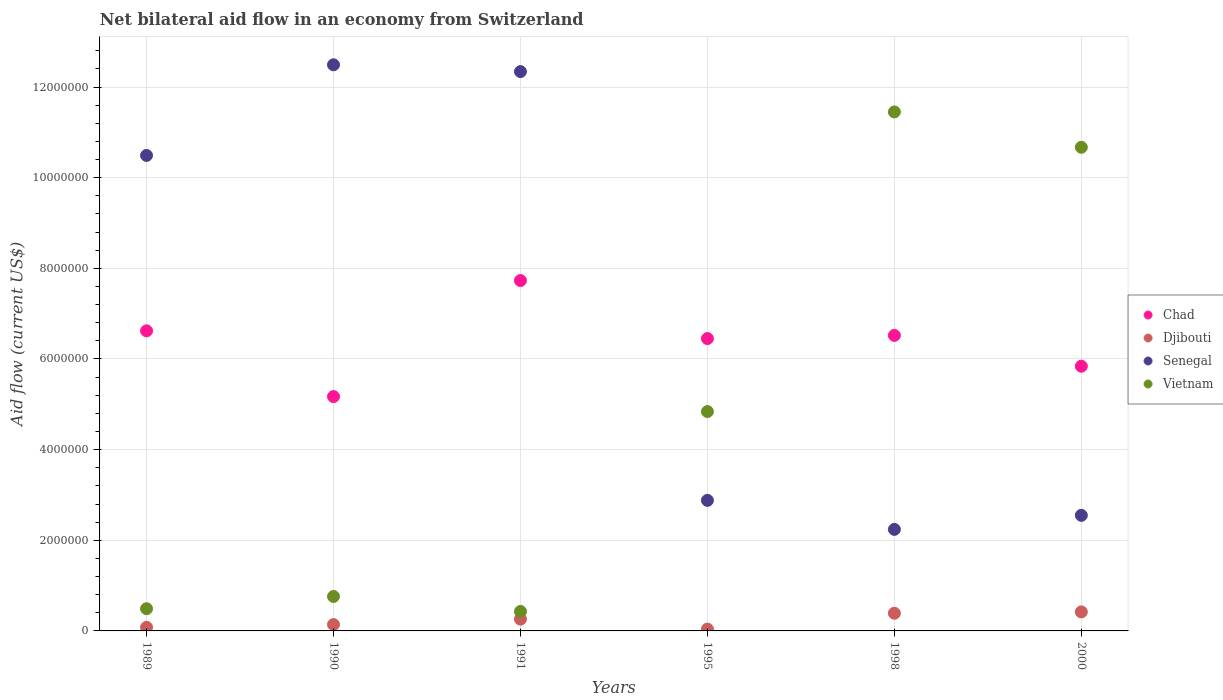How many different coloured dotlines are there?
Provide a short and direct response. 4. What is the net bilateral aid flow in Senegal in 1998?
Your answer should be compact. 2.24e+06. Across all years, what is the maximum net bilateral aid flow in Vietnam?
Your answer should be very brief. 1.14e+07. In which year was the net bilateral aid flow in Senegal minimum?
Make the answer very short. 1998. What is the total net bilateral aid flow in Chad in the graph?
Provide a succinct answer. 3.83e+07. What is the difference between the net bilateral aid flow in Vietnam in 1991 and that in 1995?
Your response must be concise. -4.41e+06. What is the difference between the net bilateral aid flow in Vietnam in 1995 and the net bilateral aid flow in Senegal in 2000?
Provide a short and direct response. 2.29e+06. What is the average net bilateral aid flow in Djibouti per year?
Make the answer very short. 2.22e+05. In the year 1989, what is the difference between the net bilateral aid flow in Djibouti and net bilateral aid flow in Chad?
Your answer should be very brief. -6.54e+06. What is the ratio of the net bilateral aid flow in Vietnam in 1995 to that in 2000?
Give a very brief answer. 0.45. Is the net bilateral aid flow in Chad in 1989 less than that in 1990?
Provide a succinct answer. No. Is the difference between the net bilateral aid flow in Djibouti in 1995 and 2000 greater than the difference between the net bilateral aid flow in Chad in 1995 and 2000?
Your answer should be compact. No. What is the difference between the highest and the second highest net bilateral aid flow in Djibouti?
Make the answer very short. 3.00e+04. Is the sum of the net bilateral aid flow in Vietnam in 1990 and 1991 greater than the maximum net bilateral aid flow in Chad across all years?
Give a very brief answer. No. Is it the case that in every year, the sum of the net bilateral aid flow in Vietnam and net bilateral aid flow in Chad  is greater than the sum of net bilateral aid flow in Senegal and net bilateral aid flow in Djibouti?
Keep it short and to the point. No. Is it the case that in every year, the sum of the net bilateral aid flow in Senegal and net bilateral aid flow in Djibouti  is greater than the net bilateral aid flow in Chad?
Ensure brevity in your answer.  No. Does the net bilateral aid flow in Vietnam monotonically increase over the years?
Offer a very short reply. No. Is the net bilateral aid flow in Djibouti strictly greater than the net bilateral aid flow in Vietnam over the years?
Make the answer very short. No. How many dotlines are there?
Keep it short and to the point. 4. How many years are there in the graph?
Your answer should be very brief. 6. Are the values on the major ticks of Y-axis written in scientific E-notation?
Give a very brief answer. No. How many legend labels are there?
Your response must be concise. 4. What is the title of the graph?
Offer a very short reply. Net bilateral aid flow in an economy from Switzerland. Does "Myanmar" appear as one of the legend labels in the graph?
Provide a succinct answer. No. What is the Aid flow (current US$) of Chad in 1989?
Your response must be concise. 6.62e+06. What is the Aid flow (current US$) of Senegal in 1989?
Make the answer very short. 1.05e+07. What is the Aid flow (current US$) in Chad in 1990?
Keep it short and to the point. 5.17e+06. What is the Aid flow (current US$) in Djibouti in 1990?
Your answer should be compact. 1.40e+05. What is the Aid flow (current US$) in Senegal in 1990?
Give a very brief answer. 1.25e+07. What is the Aid flow (current US$) in Vietnam in 1990?
Your answer should be very brief. 7.60e+05. What is the Aid flow (current US$) in Chad in 1991?
Keep it short and to the point. 7.73e+06. What is the Aid flow (current US$) in Senegal in 1991?
Make the answer very short. 1.23e+07. What is the Aid flow (current US$) of Vietnam in 1991?
Ensure brevity in your answer.  4.30e+05. What is the Aid flow (current US$) in Chad in 1995?
Make the answer very short. 6.45e+06. What is the Aid flow (current US$) of Djibouti in 1995?
Give a very brief answer. 4.00e+04. What is the Aid flow (current US$) in Senegal in 1995?
Offer a terse response. 2.88e+06. What is the Aid flow (current US$) in Vietnam in 1995?
Give a very brief answer. 4.84e+06. What is the Aid flow (current US$) of Chad in 1998?
Your response must be concise. 6.52e+06. What is the Aid flow (current US$) of Senegal in 1998?
Offer a very short reply. 2.24e+06. What is the Aid flow (current US$) in Vietnam in 1998?
Your answer should be compact. 1.14e+07. What is the Aid flow (current US$) of Chad in 2000?
Offer a very short reply. 5.84e+06. What is the Aid flow (current US$) of Djibouti in 2000?
Offer a terse response. 4.20e+05. What is the Aid flow (current US$) of Senegal in 2000?
Your answer should be very brief. 2.55e+06. What is the Aid flow (current US$) of Vietnam in 2000?
Your response must be concise. 1.07e+07. Across all years, what is the maximum Aid flow (current US$) of Chad?
Provide a short and direct response. 7.73e+06. Across all years, what is the maximum Aid flow (current US$) in Senegal?
Offer a very short reply. 1.25e+07. Across all years, what is the maximum Aid flow (current US$) of Vietnam?
Make the answer very short. 1.14e+07. Across all years, what is the minimum Aid flow (current US$) of Chad?
Make the answer very short. 5.17e+06. Across all years, what is the minimum Aid flow (current US$) in Djibouti?
Your answer should be compact. 4.00e+04. Across all years, what is the minimum Aid flow (current US$) of Senegal?
Keep it short and to the point. 2.24e+06. Across all years, what is the minimum Aid flow (current US$) of Vietnam?
Ensure brevity in your answer.  4.30e+05. What is the total Aid flow (current US$) in Chad in the graph?
Make the answer very short. 3.83e+07. What is the total Aid flow (current US$) of Djibouti in the graph?
Your answer should be very brief. 1.33e+06. What is the total Aid flow (current US$) of Senegal in the graph?
Ensure brevity in your answer.  4.30e+07. What is the total Aid flow (current US$) in Vietnam in the graph?
Make the answer very short. 2.86e+07. What is the difference between the Aid flow (current US$) in Chad in 1989 and that in 1990?
Ensure brevity in your answer.  1.45e+06. What is the difference between the Aid flow (current US$) in Djibouti in 1989 and that in 1990?
Keep it short and to the point. -6.00e+04. What is the difference between the Aid flow (current US$) in Vietnam in 1989 and that in 1990?
Make the answer very short. -2.70e+05. What is the difference between the Aid flow (current US$) of Chad in 1989 and that in 1991?
Offer a very short reply. -1.11e+06. What is the difference between the Aid flow (current US$) of Senegal in 1989 and that in 1991?
Offer a terse response. -1.85e+06. What is the difference between the Aid flow (current US$) of Djibouti in 1989 and that in 1995?
Offer a very short reply. 4.00e+04. What is the difference between the Aid flow (current US$) in Senegal in 1989 and that in 1995?
Keep it short and to the point. 7.61e+06. What is the difference between the Aid flow (current US$) in Vietnam in 1989 and that in 1995?
Your answer should be compact. -4.35e+06. What is the difference between the Aid flow (current US$) in Djibouti in 1989 and that in 1998?
Keep it short and to the point. -3.10e+05. What is the difference between the Aid flow (current US$) in Senegal in 1989 and that in 1998?
Ensure brevity in your answer.  8.25e+06. What is the difference between the Aid flow (current US$) of Vietnam in 1989 and that in 1998?
Make the answer very short. -1.10e+07. What is the difference between the Aid flow (current US$) of Chad in 1989 and that in 2000?
Keep it short and to the point. 7.80e+05. What is the difference between the Aid flow (current US$) of Djibouti in 1989 and that in 2000?
Your answer should be compact. -3.40e+05. What is the difference between the Aid flow (current US$) of Senegal in 1989 and that in 2000?
Ensure brevity in your answer.  7.94e+06. What is the difference between the Aid flow (current US$) of Vietnam in 1989 and that in 2000?
Your answer should be compact. -1.02e+07. What is the difference between the Aid flow (current US$) in Chad in 1990 and that in 1991?
Offer a terse response. -2.56e+06. What is the difference between the Aid flow (current US$) of Chad in 1990 and that in 1995?
Make the answer very short. -1.28e+06. What is the difference between the Aid flow (current US$) of Djibouti in 1990 and that in 1995?
Provide a succinct answer. 1.00e+05. What is the difference between the Aid flow (current US$) in Senegal in 1990 and that in 1995?
Your answer should be compact. 9.61e+06. What is the difference between the Aid flow (current US$) of Vietnam in 1990 and that in 1995?
Offer a very short reply. -4.08e+06. What is the difference between the Aid flow (current US$) of Chad in 1990 and that in 1998?
Your answer should be compact. -1.35e+06. What is the difference between the Aid flow (current US$) of Djibouti in 1990 and that in 1998?
Make the answer very short. -2.50e+05. What is the difference between the Aid flow (current US$) of Senegal in 1990 and that in 1998?
Offer a terse response. 1.02e+07. What is the difference between the Aid flow (current US$) of Vietnam in 1990 and that in 1998?
Your answer should be very brief. -1.07e+07. What is the difference between the Aid flow (current US$) of Chad in 1990 and that in 2000?
Give a very brief answer. -6.70e+05. What is the difference between the Aid flow (current US$) of Djibouti in 1990 and that in 2000?
Offer a terse response. -2.80e+05. What is the difference between the Aid flow (current US$) of Senegal in 1990 and that in 2000?
Offer a terse response. 9.94e+06. What is the difference between the Aid flow (current US$) in Vietnam in 1990 and that in 2000?
Ensure brevity in your answer.  -9.91e+06. What is the difference between the Aid flow (current US$) of Chad in 1991 and that in 1995?
Offer a terse response. 1.28e+06. What is the difference between the Aid flow (current US$) of Djibouti in 1991 and that in 1995?
Offer a very short reply. 2.20e+05. What is the difference between the Aid flow (current US$) of Senegal in 1991 and that in 1995?
Offer a terse response. 9.46e+06. What is the difference between the Aid flow (current US$) of Vietnam in 1991 and that in 1995?
Keep it short and to the point. -4.41e+06. What is the difference between the Aid flow (current US$) in Chad in 1991 and that in 1998?
Your response must be concise. 1.21e+06. What is the difference between the Aid flow (current US$) of Djibouti in 1991 and that in 1998?
Give a very brief answer. -1.30e+05. What is the difference between the Aid flow (current US$) in Senegal in 1991 and that in 1998?
Offer a terse response. 1.01e+07. What is the difference between the Aid flow (current US$) in Vietnam in 1991 and that in 1998?
Provide a succinct answer. -1.10e+07. What is the difference between the Aid flow (current US$) of Chad in 1991 and that in 2000?
Make the answer very short. 1.89e+06. What is the difference between the Aid flow (current US$) in Senegal in 1991 and that in 2000?
Ensure brevity in your answer.  9.79e+06. What is the difference between the Aid flow (current US$) in Vietnam in 1991 and that in 2000?
Keep it short and to the point. -1.02e+07. What is the difference between the Aid flow (current US$) of Djibouti in 1995 and that in 1998?
Offer a very short reply. -3.50e+05. What is the difference between the Aid flow (current US$) in Senegal in 1995 and that in 1998?
Your answer should be compact. 6.40e+05. What is the difference between the Aid flow (current US$) in Vietnam in 1995 and that in 1998?
Ensure brevity in your answer.  -6.61e+06. What is the difference between the Aid flow (current US$) of Chad in 1995 and that in 2000?
Your answer should be very brief. 6.10e+05. What is the difference between the Aid flow (current US$) of Djibouti in 1995 and that in 2000?
Offer a very short reply. -3.80e+05. What is the difference between the Aid flow (current US$) of Vietnam in 1995 and that in 2000?
Provide a short and direct response. -5.83e+06. What is the difference between the Aid flow (current US$) of Chad in 1998 and that in 2000?
Offer a very short reply. 6.80e+05. What is the difference between the Aid flow (current US$) in Djibouti in 1998 and that in 2000?
Make the answer very short. -3.00e+04. What is the difference between the Aid flow (current US$) in Senegal in 1998 and that in 2000?
Ensure brevity in your answer.  -3.10e+05. What is the difference between the Aid flow (current US$) of Vietnam in 1998 and that in 2000?
Your answer should be very brief. 7.80e+05. What is the difference between the Aid flow (current US$) of Chad in 1989 and the Aid flow (current US$) of Djibouti in 1990?
Give a very brief answer. 6.48e+06. What is the difference between the Aid flow (current US$) in Chad in 1989 and the Aid flow (current US$) in Senegal in 1990?
Provide a short and direct response. -5.87e+06. What is the difference between the Aid flow (current US$) in Chad in 1989 and the Aid flow (current US$) in Vietnam in 1990?
Ensure brevity in your answer.  5.86e+06. What is the difference between the Aid flow (current US$) of Djibouti in 1989 and the Aid flow (current US$) of Senegal in 1990?
Provide a short and direct response. -1.24e+07. What is the difference between the Aid flow (current US$) of Djibouti in 1989 and the Aid flow (current US$) of Vietnam in 1990?
Your response must be concise. -6.80e+05. What is the difference between the Aid flow (current US$) of Senegal in 1989 and the Aid flow (current US$) of Vietnam in 1990?
Offer a very short reply. 9.73e+06. What is the difference between the Aid flow (current US$) of Chad in 1989 and the Aid flow (current US$) of Djibouti in 1991?
Offer a very short reply. 6.36e+06. What is the difference between the Aid flow (current US$) in Chad in 1989 and the Aid flow (current US$) in Senegal in 1991?
Your answer should be very brief. -5.72e+06. What is the difference between the Aid flow (current US$) in Chad in 1989 and the Aid flow (current US$) in Vietnam in 1991?
Keep it short and to the point. 6.19e+06. What is the difference between the Aid flow (current US$) in Djibouti in 1989 and the Aid flow (current US$) in Senegal in 1991?
Give a very brief answer. -1.23e+07. What is the difference between the Aid flow (current US$) of Djibouti in 1989 and the Aid flow (current US$) of Vietnam in 1991?
Keep it short and to the point. -3.50e+05. What is the difference between the Aid flow (current US$) of Senegal in 1989 and the Aid flow (current US$) of Vietnam in 1991?
Make the answer very short. 1.01e+07. What is the difference between the Aid flow (current US$) in Chad in 1989 and the Aid flow (current US$) in Djibouti in 1995?
Your answer should be very brief. 6.58e+06. What is the difference between the Aid flow (current US$) of Chad in 1989 and the Aid flow (current US$) of Senegal in 1995?
Your answer should be compact. 3.74e+06. What is the difference between the Aid flow (current US$) in Chad in 1989 and the Aid flow (current US$) in Vietnam in 1995?
Provide a short and direct response. 1.78e+06. What is the difference between the Aid flow (current US$) of Djibouti in 1989 and the Aid flow (current US$) of Senegal in 1995?
Your answer should be compact. -2.80e+06. What is the difference between the Aid flow (current US$) of Djibouti in 1989 and the Aid flow (current US$) of Vietnam in 1995?
Make the answer very short. -4.76e+06. What is the difference between the Aid flow (current US$) in Senegal in 1989 and the Aid flow (current US$) in Vietnam in 1995?
Your answer should be compact. 5.65e+06. What is the difference between the Aid flow (current US$) in Chad in 1989 and the Aid flow (current US$) in Djibouti in 1998?
Keep it short and to the point. 6.23e+06. What is the difference between the Aid flow (current US$) of Chad in 1989 and the Aid flow (current US$) of Senegal in 1998?
Give a very brief answer. 4.38e+06. What is the difference between the Aid flow (current US$) in Chad in 1989 and the Aid flow (current US$) in Vietnam in 1998?
Give a very brief answer. -4.83e+06. What is the difference between the Aid flow (current US$) in Djibouti in 1989 and the Aid flow (current US$) in Senegal in 1998?
Make the answer very short. -2.16e+06. What is the difference between the Aid flow (current US$) of Djibouti in 1989 and the Aid flow (current US$) of Vietnam in 1998?
Offer a very short reply. -1.14e+07. What is the difference between the Aid flow (current US$) of Senegal in 1989 and the Aid flow (current US$) of Vietnam in 1998?
Your response must be concise. -9.60e+05. What is the difference between the Aid flow (current US$) in Chad in 1989 and the Aid flow (current US$) in Djibouti in 2000?
Provide a succinct answer. 6.20e+06. What is the difference between the Aid flow (current US$) in Chad in 1989 and the Aid flow (current US$) in Senegal in 2000?
Provide a short and direct response. 4.07e+06. What is the difference between the Aid flow (current US$) of Chad in 1989 and the Aid flow (current US$) of Vietnam in 2000?
Give a very brief answer. -4.05e+06. What is the difference between the Aid flow (current US$) in Djibouti in 1989 and the Aid flow (current US$) in Senegal in 2000?
Provide a succinct answer. -2.47e+06. What is the difference between the Aid flow (current US$) of Djibouti in 1989 and the Aid flow (current US$) of Vietnam in 2000?
Offer a very short reply. -1.06e+07. What is the difference between the Aid flow (current US$) of Chad in 1990 and the Aid flow (current US$) of Djibouti in 1991?
Your answer should be very brief. 4.91e+06. What is the difference between the Aid flow (current US$) of Chad in 1990 and the Aid flow (current US$) of Senegal in 1991?
Your response must be concise. -7.17e+06. What is the difference between the Aid flow (current US$) of Chad in 1990 and the Aid flow (current US$) of Vietnam in 1991?
Ensure brevity in your answer.  4.74e+06. What is the difference between the Aid flow (current US$) of Djibouti in 1990 and the Aid flow (current US$) of Senegal in 1991?
Offer a very short reply. -1.22e+07. What is the difference between the Aid flow (current US$) in Djibouti in 1990 and the Aid flow (current US$) in Vietnam in 1991?
Offer a very short reply. -2.90e+05. What is the difference between the Aid flow (current US$) in Senegal in 1990 and the Aid flow (current US$) in Vietnam in 1991?
Ensure brevity in your answer.  1.21e+07. What is the difference between the Aid flow (current US$) of Chad in 1990 and the Aid flow (current US$) of Djibouti in 1995?
Your answer should be very brief. 5.13e+06. What is the difference between the Aid flow (current US$) in Chad in 1990 and the Aid flow (current US$) in Senegal in 1995?
Provide a short and direct response. 2.29e+06. What is the difference between the Aid flow (current US$) of Djibouti in 1990 and the Aid flow (current US$) of Senegal in 1995?
Provide a short and direct response. -2.74e+06. What is the difference between the Aid flow (current US$) in Djibouti in 1990 and the Aid flow (current US$) in Vietnam in 1995?
Keep it short and to the point. -4.70e+06. What is the difference between the Aid flow (current US$) in Senegal in 1990 and the Aid flow (current US$) in Vietnam in 1995?
Make the answer very short. 7.65e+06. What is the difference between the Aid flow (current US$) of Chad in 1990 and the Aid flow (current US$) of Djibouti in 1998?
Keep it short and to the point. 4.78e+06. What is the difference between the Aid flow (current US$) in Chad in 1990 and the Aid flow (current US$) in Senegal in 1998?
Give a very brief answer. 2.93e+06. What is the difference between the Aid flow (current US$) in Chad in 1990 and the Aid flow (current US$) in Vietnam in 1998?
Your response must be concise. -6.28e+06. What is the difference between the Aid flow (current US$) in Djibouti in 1990 and the Aid flow (current US$) in Senegal in 1998?
Offer a terse response. -2.10e+06. What is the difference between the Aid flow (current US$) of Djibouti in 1990 and the Aid flow (current US$) of Vietnam in 1998?
Keep it short and to the point. -1.13e+07. What is the difference between the Aid flow (current US$) in Senegal in 1990 and the Aid flow (current US$) in Vietnam in 1998?
Provide a short and direct response. 1.04e+06. What is the difference between the Aid flow (current US$) in Chad in 1990 and the Aid flow (current US$) in Djibouti in 2000?
Provide a succinct answer. 4.75e+06. What is the difference between the Aid flow (current US$) of Chad in 1990 and the Aid flow (current US$) of Senegal in 2000?
Your answer should be compact. 2.62e+06. What is the difference between the Aid flow (current US$) of Chad in 1990 and the Aid flow (current US$) of Vietnam in 2000?
Your response must be concise. -5.50e+06. What is the difference between the Aid flow (current US$) in Djibouti in 1990 and the Aid flow (current US$) in Senegal in 2000?
Offer a very short reply. -2.41e+06. What is the difference between the Aid flow (current US$) of Djibouti in 1990 and the Aid flow (current US$) of Vietnam in 2000?
Keep it short and to the point. -1.05e+07. What is the difference between the Aid flow (current US$) in Senegal in 1990 and the Aid flow (current US$) in Vietnam in 2000?
Ensure brevity in your answer.  1.82e+06. What is the difference between the Aid flow (current US$) in Chad in 1991 and the Aid flow (current US$) in Djibouti in 1995?
Your answer should be compact. 7.69e+06. What is the difference between the Aid flow (current US$) of Chad in 1991 and the Aid flow (current US$) of Senegal in 1995?
Keep it short and to the point. 4.85e+06. What is the difference between the Aid flow (current US$) in Chad in 1991 and the Aid flow (current US$) in Vietnam in 1995?
Your answer should be compact. 2.89e+06. What is the difference between the Aid flow (current US$) of Djibouti in 1991 and the Aid flow (current US$) of Senegal in 1995?
Provide a succinct answer. -2.62e+06. What is the difference between the Aid flow (current US$) in Djibouti in 1991 and the Aid flow (current US$) in Vietnam in 1995?
Your answer should be compact. -4.58e+06. What is the difference between the Aid flow (current US$) of Senegal in 1991 and the Aid flow (current US$) of Vietnam in 1995?
Provide a succinct answer. 7.50e+06. What is the difference between the Aid flow (current US$) in Chad in 1991 and the Aid flow (current US$) in Djibouti in 1998?
Offer a terse response. 7.34e+06. What is the difference between the Aid flow (current US$) of Chad in 1991 and the Aid flow (current US$) of Senegal in 1998?
Keep it short and to the point. 5.49e+06. What is the difference between the Aid flow (current US$) of Chad in 1991 and the Aid flow (current US$) of Vietnam in 1998?
Make the answer very short. -3.72e+06. What is the difference between the Aid flow (current US$) in Djibouti in 1991 and the Aid flow (current US$) in Senegal in 1998?
Make the answer very short. -1.98e+06. What is the difference between the Aid flow (current US$) in Djibouti in 1991 and the Aid flow (current US$) in Vietnam in 1998?
Provide a succinct answer. -1.12e+07. What is the difference between the Aid flow (current US$) of Senegal in 1991 and the Aid flow (current US$) of Vietnam in 1998?
Your answer should be very brief. 8.90e+05. What is the difference between the Aid flow (current US$) of Chad in 1991 and the Aid flow (current US$) of Djibouti in 2000?
Offer a very short reply. 7.31e+06. What is the difference between the Aid flow (current US$) of Chad in 1991 and the Aid flow (current US$) of Senegal in 2000?
Make the answer very short. 5.18e+06. What is the difference between the Aid flow (current US$) in Chad in 1991 and the Aid flow (current US$) in Vietnam in 2000?
Ensure brevity in your answer.  -2.94e+06. What is the difference between the Aid flow (current US$) in Djibouti in 1991 and the Aid flow (current US$) in Senegal in 2000?
Offer a very short reply. -2.29e+06. What is the difference between the Aid flow (current US$) of Djibouti in 1991 and the Aid flow (current US$) of Vietnam in 2000?
Ensure brevity in your answer.  -1.04e+07. What is the difference between the Aid flow (current US$) of Senegal in 1991 and the Aid flow (current US$) of Vietnam in 2000?
Provide a short and direct response. 1.67e+06. What is the difference between the Aid flow (current US$) of Chad in 1995 and the Aid flow (current US$) of Djibouti in 1998?
Ensure brevity in your answer.  6.06e+06. What is the difference between the Aid flow (current US$) in Chad in 1995 and the Aid flow (current US$) in Senegal in 1998?
Give a very brief answer. 4.21e+06. What is the difference between the Aid flow (current US$) of Chad in 1995 and the Aid flow (current US$) of Vietnam in 1998?
Make the answer very short. -5.00e+06. What is the difference between the Aid flow (current US$) of Djibouti in 1995 and the Aid flow (current US$) of Senegal in 1998?
Make the answer very short. -2.20e+06. What is the difference between the Aid flow (current US$) of Djibouti in 1995 and the Aid flow (current US$) of Vietnam in 1998?
Keep it short and to the point. -1.14e+07. What is the difference between the Aid flow (current US$) in Senegal in 1995 and the Aid flow (current US$) in Vietnam in 1998?
Your answer should be very brief. -8.57e+06. What is the difference between the Aid flow (current US$) in Chad in 1995 and the Aid flow (current US$) in Djibouti in 2000?
Your answer should be very brief. 6.03e+06. What is the difference between the Aid flow (current US$) of Chad in 1995 and the Aid flow (current US$) of Senegal in 2000?
Keep it short and to the point. 3.90e+06. What is the difference between the Aid flow (current US$) of Chad in 1995 and the Aid flow (current US$) of Vietnam in 2000?
Give a very brief answer. -4.22e+06. What is the difference between the Aid flow (current US$) in Djibouti in 1995 and the Aid flow (current US$) in Senegal in 2000?
Offer a terse response. -2.51e+06. What is the difference between the Aid flow (current US$) in Djibouti in 1995 and the Aid flow (current US$) in Vietnam in 2000?
Keep it short and to the point. -1.06e+07. What is the difference between the Aid flow (current US$) of Senegal in 1995 and the Aid flow (current US$) of Vietnam in 2000?
Make the answer very short. -7.79e+06. What is the difference between the Aid flow (current US$) in Chad in 1998 and the Aid flow (current US$) in Djibouti in 2000?
Provide a short and direct response. 6.10e+06. What is the difference between the Aid flow (current US$) in Chad in 1998 and the Aid flow (current US$) in Senegal in 2000?
Your answer should be very brief. 3.97e+06. What is the difference between the Aid flow (current US$) in Chad in 1998 and the Aid flow (current US$) in Vietnam in 2000?
Keep it short and to the point. -4.15e+06. What is the difference between the Aid flow (current US$) of Djibouti in 1998 and the Aid flow (current US$) of Senegal in 2000?
Give a very brief answer. -2.16e+06. What is the difference between the Aid flow (current US$) of Djibouti in 1998 and the Aid flow (current US$) of Vietnam in 2000?
Your answer should be very brief. -1.03e+07. What is the difference between the Aid flow (current US$) in Senegal in 1998 and the Aid flow (current US$) in Vietnam in 2000?
Offer a terse response. -8.43e+06. What is the average Aid flow (current US$) of Chad per year?
Your response must be concise. 6.39e+06. What is the average Aid flow (current US$) of Djibouti per year?
Your response must be concise. 2.22e+05. What is the average Aid flow (current US$) in Senegal per year?
Your answer should be compact. 7.16e+06. What is the average Aid flow (current US$) of Vietnam per year?
Offer a terse response. 4.77e+06. In the year 1989, what is the difference between the Aid flow (current US$) of Chad and Aid flow (current US$) of Djibouti?
Provide a succinct answer. 6.54e+06. In the year 1989, what is the difference between the Aid flow (current US$) in Chad and Aid flow (current US$) in Senegal?
Provide a succinct answer. -3.87e+06. In the year 1989, what is the difference between the Aid flow (current US$) in Chad and Aid flow (current US$) in Vietnam?
Keep it short and to the point. 6.13e+06. In the year 1989, what is the difference between the Aid flow (current US$) of Djibouti and Aid flow (current US$) of Senegal?
Ensure brevity in your answer.  -1.04e+07. In the year 1989, what is the difference between the Aid flow (current US$) in Djibouti and Aid flow (current US$) in Vietnam?
Make the answer very short. -4.10e+05. In the year 1989, what is the difference between the Aid flow (current US$) in Senegal and Aid flow (current US$) in Vietnam?
Your answer should be compact. 1.00e+07. In the year 1990, what is the difference between the Aid flow (current US$) of Chad and Aid flow (current US$) of Djibouti?
Give a very brief answer. 5.03e+06. In the year 1990, what is the difference between the Aid flow (current US$) of Chad and Aid flow (current US$) of Senegal?
Keep it short and to the point. -7.32e+06. In the year 1990, what is the difference between the Aid flow (current US$) in Chad and Aid flow (current US$) in Vietnam?
Make the answer very short. 4.41e+06. In the year 1990, what is the difference between the Aid flow (current US$) in Djibouti and Aid flow (current US$) in Senegal?
Offer a terse response. -1.24e+07. In the year 1990, what is the difference between the Aid flow (current US$) of Djibouti and Aid flow (current US$) of Vietnam?
Give a very brief answer. -6.20e+05. In the year 1990, what is the difference between the Aid flow (current US$) in Senegal and Aid flow (current US$) in Vietnam?
Offer a very short reply. 1.17e+07. In the year 1991, what is the difference between the Aid flow (current US$) of Chad and Aid flow (current US$) of Djibouti?
Make the answer very short. 7.47e+06. In the year 1991, what is the difference between the Aid flow (current US$) of Chad and Aid flow (current US$) of Senegal?
Make the answer very short. -4.61e+06. In the year 1991, what is the difference between the Aid flow (current US$) in Chad and Aid flow (current US$) in Vietnam?
Your response must be concise. 7.30e+06. In the year 1991, what is the difference between the Aid flow (current US$) of Djibouti and Aid flow (current US$) of Senegal?
Your response must be concise. -1.21e+07. In the year 1991, what is the difference between the Aid flow (current US$) of Senegal and Aid flow (current US$) of Vietnam?
Make the answer very short. 1.19e+07. In the year 1995, what is the difference between the Aid flow (current US$) in Chad and Aid flow (current US$) in Djibouti?
Provide a short and direct response. 6.41e+06. In the year 1995, what is the difference between the Aid flow (current US$) of Chad and Aid flow (current US$) of Senegal?
Keep it short and to the point. 3.57e+06. In the year 1995, what is the difference between the Aid flow (current US$) of Chad and Aid flow (current US$) of Vietnam?
Offer a very short reply. 1.61e+06. In the year 1995, what is the difference between the Aid flow (current US$) in Djibouti and Aid flow (current US$) in Senegal?
Provide a short and direct response. -2.84e+06. In the year 1995, what is the difference between the Aid flow (current US$) of Djibouti and Aid flow (current US$) of Vietnam?
Offer a very short reply. -4.80e+06. In the year 1995, what is the difference between the Aid flow (current US$) in Senegal and Aid flow (current US$) in Vietnam?
Your answer should be very brief. -1.96e+06. In the year 1998, what is the difference between the Aid flow (current US$) of Chad and Aid flow (current US$) of Djibouti?
Make the answer very short. 6.13e+06. In the year 1998, what is the difference between the Aid flow (current US$) of Chad and Aid flow (current US$) of Senegal?
Provide a succinct answer. 4.28e+06. In the year 1998, what is the difference between the Aid flow (current US$) of Chad and Aid flow (current US$) of Vietnam?
Your response must be concise. -4.93e+06. In the year 1998, what is the difference between the Aid flow (current US$) in Djibouti and Aid flow (current US$) in Senegal?
Your answer should be compact. -1.85e+06. In the year 1998, what is the difference between the Aid flow (current US$) of Djibouti and Aid flow (current US$) of Vietnam?
Provide a succinct answer. -1.11e+07. In the year 1998, what is the difference between the Aid flow (current US$) of Senegal and Aid flow (current US$) of Vietnam?
Your response must be concise. -9.21e+06. In the year 2000, what is the difference between the Aid flow (current US$) of Chad and Aid flow (current US$) of Djibouti?
Provide a succinct answer. 5.42e+06. In the year 2000, what is the difference between the Aid flow (current US$) of Chad and Aid flow (current US$) of Senegal?
Your response must be concise. 3.29e+06. In the year 2000, what is the difference between the Aid flow (current US$) in Chad and Aid flow (current US$) in Vietnam?
Provide a succinct answer. -4.83e+06. In the year 2000, what is the difference between the Aid flow (current US$) in Djibouti and Aid flow (current US$) in Senegal?
Your answer should be very brief. -2.13e+06. In the year 2000, what is the difference between the Aid flow (current US$) of Djibouti and Aid flow (current US$) of Vietnam?
Keep it short and to the point. -1.02e+07. In the year 2000, what is the difference between the Aid flow (current US$) of Senegal and Aid flow (current US$) of Vietnam?
Ensure brevity in your answer.  -8.12e+06. What is the ratio of the Aid flow (current US$) in Chad in 1989 to that in 1990?
Ensure brevity in your answer.  1.28. What is the ratio of the Aid flow (current US$) of Senegal in 1989 to that in 1990?
Ensure brevity in your answer.  0.84. What is the ratio of the Aid flow (current US$) of Vietnam in 1989 to that in 1990?
Ensure brevity in your answer.  0.64. What is the ratio of the Aid flow (current US$) in Chad in 1989 to that in 1991?
Give a very brief answer. 0.86. What is the ratio of the Aid flow (current US$) in Djibouti in 1989 to that in 1991?
Your answer should be very brief. 0.31. What is the ratio of the Aid flow (current US$) of Senegal in 1989 to that in 1991?
Provide a short and direct response. 0.85. What is the ratio of the Aid flow (current US$) in Vietnam in 1989 to that in 1991?
Make the answer very short. 1.14. What is the ratio of the Aid flow (current US$) in Chad in 1989 to that in 1995?
Offer a terse response. 1.03. What is the ratio of the Aid flow (current US$) of Senegal in 1989 to that in 1995?
Give a very brief answer. 3.64. What is the ratio of the Aid flow (current US$) of Vietnam in 1989 to that in 1995?
Your answer should be very brief. 0.1. What is the ratio of the Aid flow (current US$) in Chad in 1989 to that in 1998?
Your answer should be very brief. 1.02. What is the ratio of the Aid flow (current US$) of Djibouti in 1989 to that in 1998?
Your response must be concise. 0.21. What is the ratio of the Aid flow (current US$) in Senegal in 1989 to that in 1998?
Provide a succinct answer. 4.68. What is the ratio of the Aid flow (current US$) in Vietnam in 1989 to that in 1998?
Make the answer very short. 0.04. What is the ratio of the Aid flow (current US$) in Chad in 1989 to that in 2000?
Your answer should be very brief. 1.13. What is the ratio of the Aid flow (current US$) of Djibouti in 1989 to that in 2000?
Offer a very short reply. 0.19. What is the ratio of the Aid flow (current US$) in Senegal in 1989 to that in 2000?
Ensure brevity in your answer.  4.11. What is the ratio of the Aid flow (current US$) in Vietnam in 1989 to that in 2000?
Offer a very short reply. 0.05. What is the ratio of the Aid flow (current US$) of Chad in 1990 to that in 1991?
Provide a short and direct response. 0.67. What is the ratio of the Aid flow (current US$) of Djibouti in 1990 to that in 1991?
Ensure brevity in your answer.  0.54. What is the ratio of the Aid flow (current US$) of Senegal in 1990 to that in 1991?
Provide a succinct answer. 1.01. What is the ratio of the Aid flow (current US$) of Vietnam in 1990 to that in 1991?
Provide a succinct answer. 1.77. What is the ratio of the Aid flow (current US$) of Chad in 1990 to that in 1995?
Provide a succinct answer. 0.8. What is the ratio of the Aid flow (current US$) of Senegal in 1990 to that in 1995?
Provide a succinct answer. 4.34. What is the ratio of the Aid flow (current US$) of Vietnam in 1990 to that in 1995?
Provide a succinct answer. 0.16. What is the ratio of the Aid flow (current US$) in Chad in 1990 to that in 1998?
Ensure brevity in your answer.  0.79. What is the ratio of the Aid flow (current US$) in Djibouti in 1990 to that in 1998?
Your answer should be compact. 0.36. What is the ratio of the Aid flow (current US$) of Senegal in 1990 to that in 1998?
Offer a very short reply. 5.58. What is the ratio of the Aid flow (current US$) in Vietnam in 1990 to that in 1998?
Give a very brief answer. 0.07. What is the ratio of the Aid flow (current US$) in Chad in 1990 to that in 2000?
Keep it short and to the point. 0.89. What is the ratio of the Aid flow (current US$) in Djibouti in 1990 to that in 2000?
Ensure brevity in your answer.  0.33. What is the ratio of the Aid flow (current US$) in Senegal in 1990 to that in 2000?
Provide a succinct answer. 4.9. What is the ratio of the Aid flow (current US$) of Vietnam in 1990 to that in 2000?
Give a very brief answer. 0.07. What is the ratio of the Aid flow (current US$) in Chad in 1991 to that in 1995?
Your answer should be compact. 1.2. What is the ratio of the Aid flow (current US$) in Djibouti in 1991 to that in 1995?
Make the answer very short. 6.5. What is the ratio of the Aid flow (current US$) in Senegal in 1991 to that in 1995?
Make the answer very short. 4.28. What is the ratio of the Aid flow (current US$) in Vietnam in 1991 to that in 1995?
Provide a short and direct response. 0.09. What is the ratio of the Aid flow (current US$) of Chad in 1991 to that in 1998?
Give a very brief answer. 1.19. What is the ratio of the Aid flow (current US$) of Djibouti in 1991 to that in 1998?
Your response must be concise. 0.67. What is the ratio of the Aid flow (current US$) in Senegal in 1991 to that in 1998?
Keep it short and to the point. 5.51. What is the ratio of the Aid flow (current US$) in Vietnam in 1991 to that in 1998?
Provide a short and direct response. 0.04. What is the ratio of the Aid flow (current US$) in Chad in 1991 to that in 2000?
Your response must be concise. 1.32. What is the ratio of the Aid flow (current US$) in Djibouti in 1991 to that in 2000?
Make the answer very short. 0.62. What is the ratio of the Aid flow (current US$) of Senegal in 1991 to that in 2000?
Your answer should be very brief. 4.84. What is the ratio of the Aid flow (current US$) in Vietnam in 1991 to that in 2000?
Offer a very short reply. 0.04. What is the ratio of the Aid flow (current US$) of Chad in 1995 to that in 1998?
Offer a terse response. 0.99. What is the ratio of the Aid flow (current US$) in Djibouti in 1995 to that in 1998?
Provide a short and direct response. 0.1. What is the ratio of the Aid flow (current US$) of Senegal in 1995 to that in 1998?
Offer a very short reply. 1.29. What is the ratio of the Aid flow (current US$) in Vietnam in 1995 to that in 1998?
Provide a succinct answer. 0.42. What is the ratio of the Aid flow (current US$) of Chad in 1995 to that in 2000?
Provide a short and direct response. 1.1. What is the ratio of the Aid flow (current US$) in Djibouti in 1995 to that in 2000?
Provide a succinct answer. 0.1. What is the ratio of the Aid flow (current US$) of Senegal in 1995 to that in 2000?
Provide a succinct answer. 1.13. What is the ratio of the Aid flow (current US$) of Vietnam in 1995 to that in 2000?
Provide a short and direct response. 0.45. What is the ratio of the Aid flow (current US$) in Chad in 1998 to that in 2000?
Your answer should be very brief. 1.12. What is the ratio of the Aid flow (current US$) of Senegal in 1998 to that in 2000?
Keep it short and to the point. 0.88. What is the ratio of the Aid flow (current US$) in Vietnam in 1998 to that in 2000?
Offer a very short reply. 1.07. What is the difference between the highest and the second highest Aid flow (current US$) in Chad?
Give a very brief answer. 1.11e+06. What is the difference between the highest and the second highest Aid flow (current US$) of Vietnam?
Your answer should be very brief. 7.80e+05. What is the difference between the highest and the lowest Aid flow (current US$) of Chad?
Give a very brief answer. 2.56e+06. What is the difference between the highest and the lowest Aid flow (current US$) of Djibouti?
Give a very brief answer. 3.80e+05. What is the difference between the highest and the lowest Aid flow (current US$) in Senegal?
Provide a succinct answer. 1.02e+07. What is the difference between the highest and the lowest Aid flow (current US$) of Vietnam?
Offer a very short reply. 1.10e+07. 